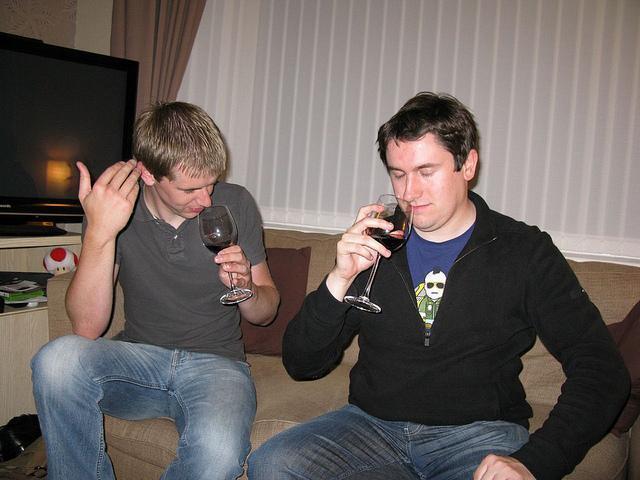Who manufactures the game that the stuffed animal is inspired by?
Indicate the correct response by choosing from the four available options to answer the question.
Options: Sega, atari, microsoft, nintendo. Nintendo. 